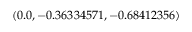Convert formula to latex. <formula><loc_0><loc_0><loc_500><loc_500>( 0 . 0 , - 0 . 3 6 3 3 4 5 7 1 , - 0 . 6 8 4 1 2 3 5 6 )</formula> 